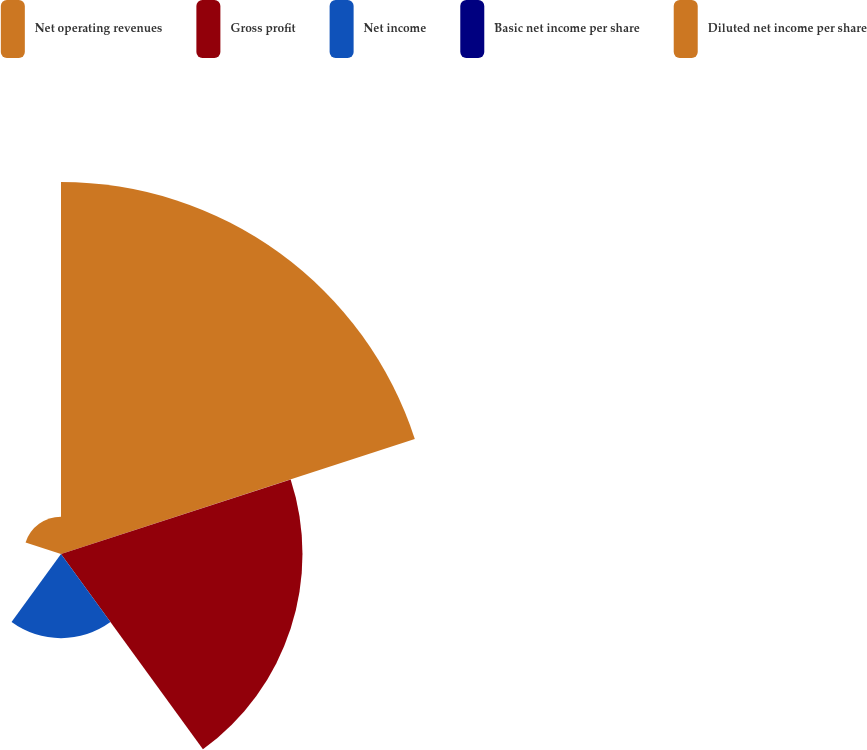Convert chart. <chart><loc_0><loc_0><loc_500><loc_500><pie_chart><fcel>Net operating revenues<fcel>Gross profit<fcel>Net income<fcel>Basic net income per share<fcel>Diluted net income per share<nl><fcel>50.62%<fcel>32.86%<fcel>11.45%<fcel>0.0%<fcel>5.07%<nl></chart> 